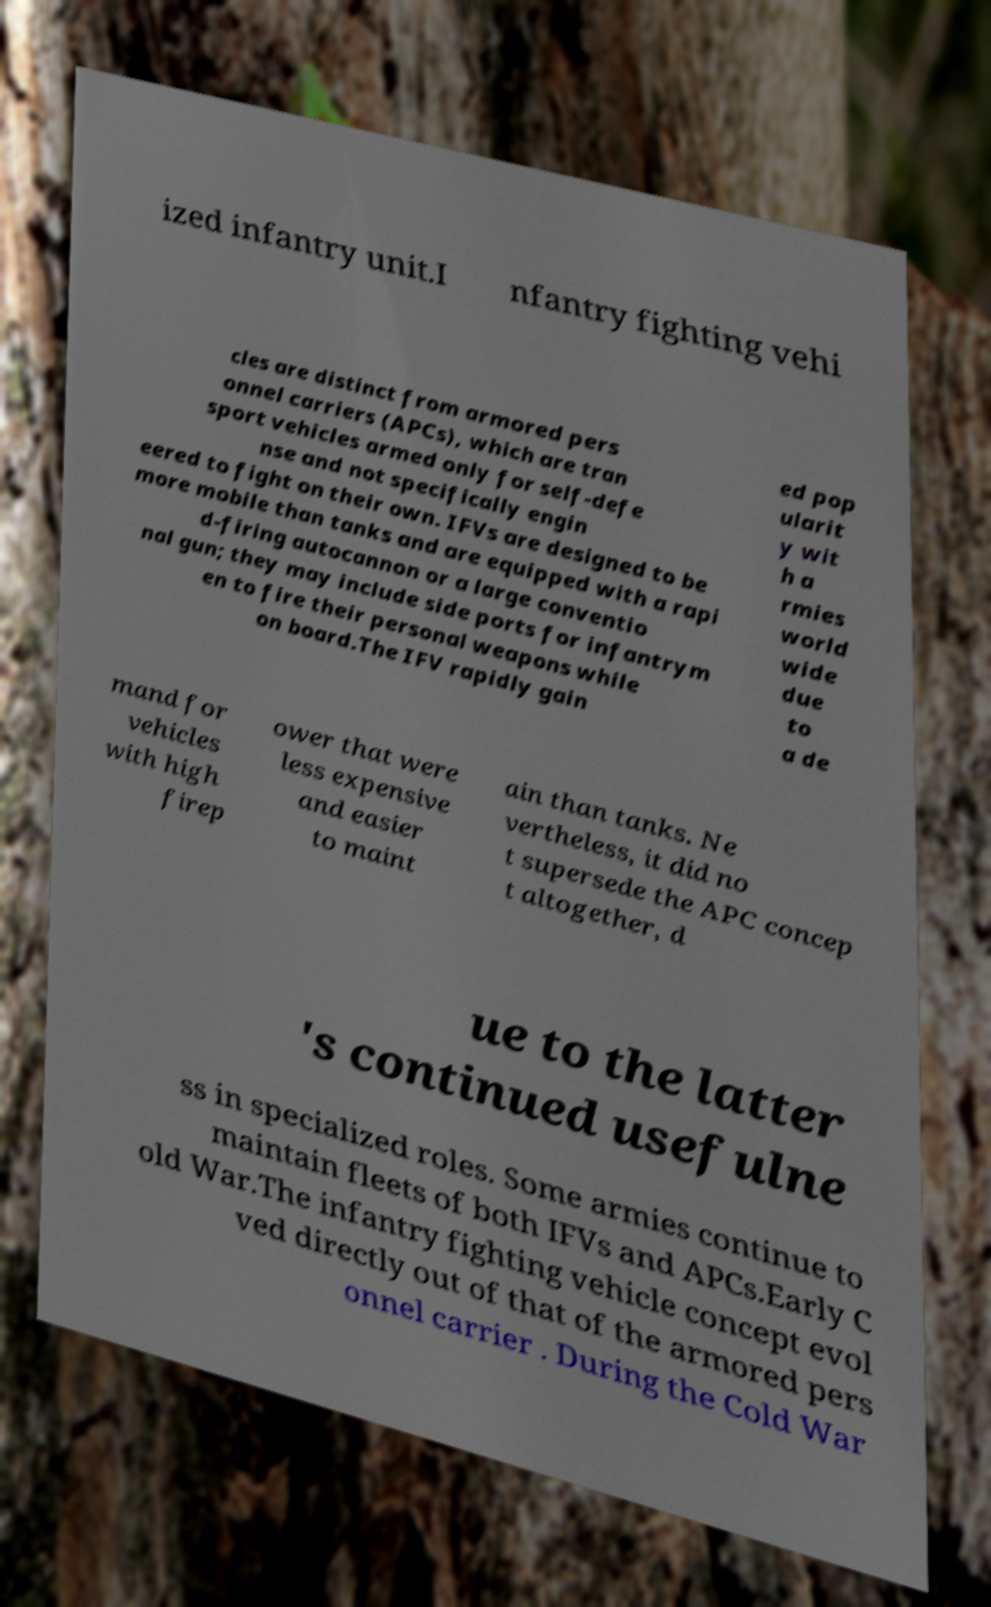There's text embedded in this image that I need extracted. Can you transcribe it verbatim? ized infantry unit.I nfantry fighting vehi cles are distinct from armored pers onnel carriers (APCs), which are tran sport vehicles armed only for self-defe nse and not specifically engin eered to fight on their own. IFVs are designed to be more mobile than tanks and are equipped with a rapi d-firing autocannon or a large conventio nal gun; they may include side ports for infantrym en to fire their personal weapons while on board.The IFV rapidly gain ed pop ularit y wit h a rmies world wide due to a de mand for vehicles with high firep ower that were less expensive and easier to maint ain than tanks. Ne vertheless, it did no t supersede the APC concep t altogether, d ue to the latter 's continued usefulne ss in specialized roles. Some armies continue to maintain fleets of both IFVs and APCs.Early C old War.The infantry fighting vehicle concept evol ved directly out of that of the armored pers onnel carrier . During the Cold War 